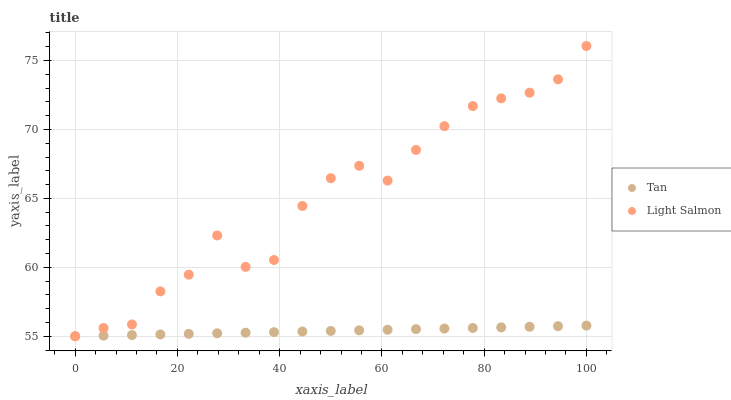Does Tan have the minimum area under the curve?
Answer yes or no. Yes. Does Light Salmon have the maximum area under the curve?
Answer yes or no. Yes. Does Light Salmon have the minimum area under the curve?
Answer yes or no. No. Is Tan the smoothest?
Answer yes or no. Yes. Is Light Salmon the roughest?
Answer yes or no. Yes. Is Light Salmon the smoothest?
Answer yes or no. No. Does Tan have the lowest value?
Answer yes or no. Yes. Does Light Salmon have the highest value?
Answer yes or no. Yes. Does Tan intersect Light Salmon?
Answer yes or no. Yes. Is Tan less than Light Salmon?
Answer yes or no. No. Is Tan greater than Light Salmon?
Answer yes or no. No. 